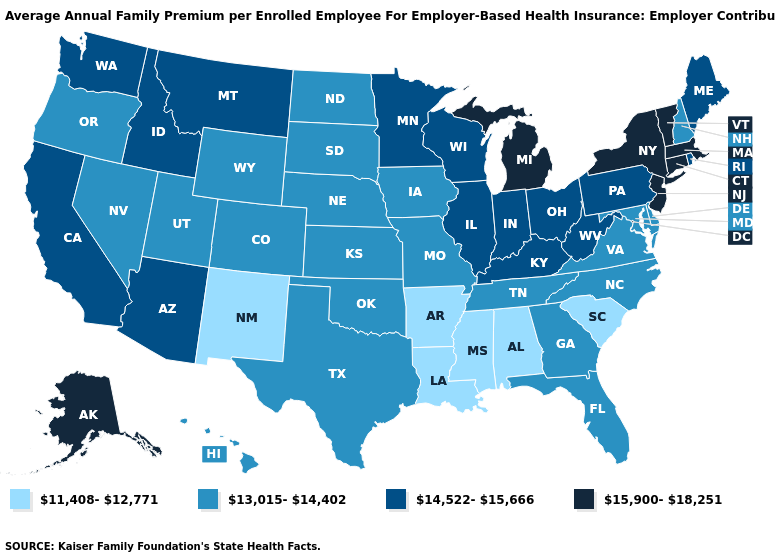Name the states that have a value in the range 13,015-14,402?
Give a very brief answer. Colorado, Delaware, Florida, Georgia, Hawaii, Iowa, Kansas, Maryland, Missouri, Nebraska, Nevada, New Hampshire, North Carolina, North Dakota, Oklahoma, Oregon, South Dakota, Tennessee, Texas, Utah, Virginia, Wyoming. Which states have the lowest value in the USA?
Short answer required. Alabama, Arkansas, Louisiana, Mississippi, New Mexico, South Carolina. Is the legend a continuous bar?
Short answer required. No. Does Colorado have the lowest value in the West?
Short answer required. No. Does the map have missing data?
Short answer required. No. Name the states that have a value in the range 13,015-14,402?
Be succinct. Colorado, Delaware, Florida, Georgia, Hawaii, Iowa, Kansas, Maryland, Missouri, Nebraska, Nevada, New Hampshire, North Carolina, North Dakota, Oklahoma, Oregon, South Dakota, Tennessee, Texas, Utah, Virginia, Wyoming. What is the value of Washington?
Be succinct. 14,522-15,666. Among the states that border Tennessee , does Virginia have the lowest value?
Concise answer only. No. Does the map have missing data?
Quick response, please. No. Is the legend a continuous bar?
Concise answer only. No. Name the states that have a value in the range 15,900-18,251?
Short answer required. Alaska, Connecticut, Massachusetts, Michigan, New Jersey, New York, Vermont. Is the legend a continuous bar?
Short answer required. No. Name the states that have a value in the range 14,522-15,666?
Answer briefly. Arizona, California, Idaho, Illinois, Indiana, Kentucky, Maine, Minnesota, Montana, Ohio, Pennsylvania, Rhode Island, Washington, West Virginia, Wisconsin. Does Vermont have the highest value in the USA?
Quick response, please. Yes. Does Alaska have a lower value than Kansas?
Write a very short answer. No. 